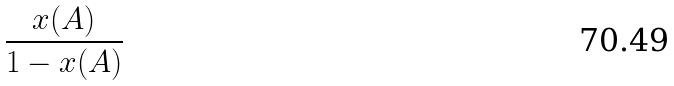Convert formula to latex. <formula><loc_0><loc_0><loc_500><loc_500>\frac { x ( A ) } { 1 - x ( A ) }</formula> 